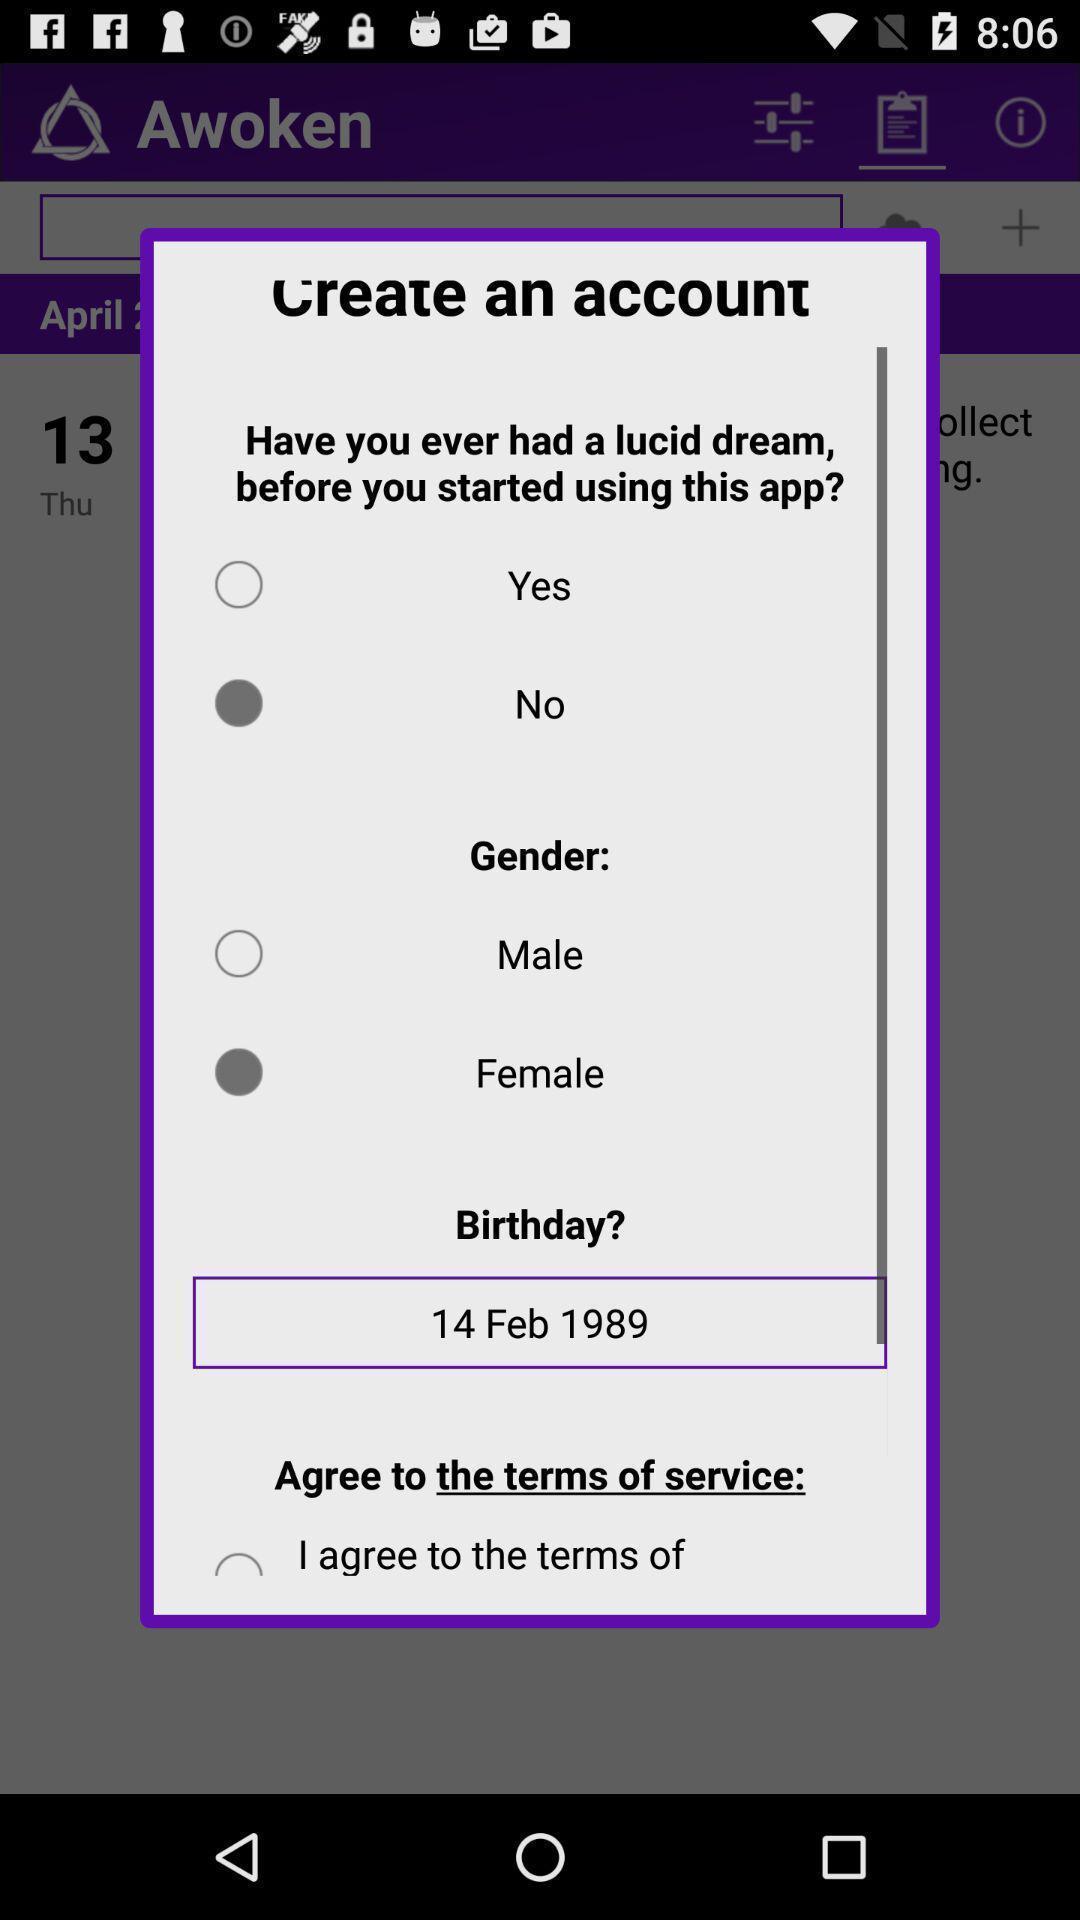What can you discern from this picture? Popup to create account in the dream journal application. 